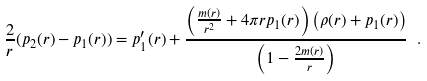<formula> <loc_0><loc_0><loc_500><loc_500>\frac { 2 } { r } ( p _ { 2 } ( r ) - p _ { 1 } ( r ) ) = p _ { 1 } ^ { \prime } ( r ) + \frac { \left ( \frac { m ( r ) } { r ^ { 2 } } + 4 \pi r p _ { 1 } ( r ) \right ) \left ( \rho ( r ) + p _ { 1 } ( r ) \right ) } { \left ( 1 - \frac { 2 m ( r ) } { r } \right ) } \ .</formula> 